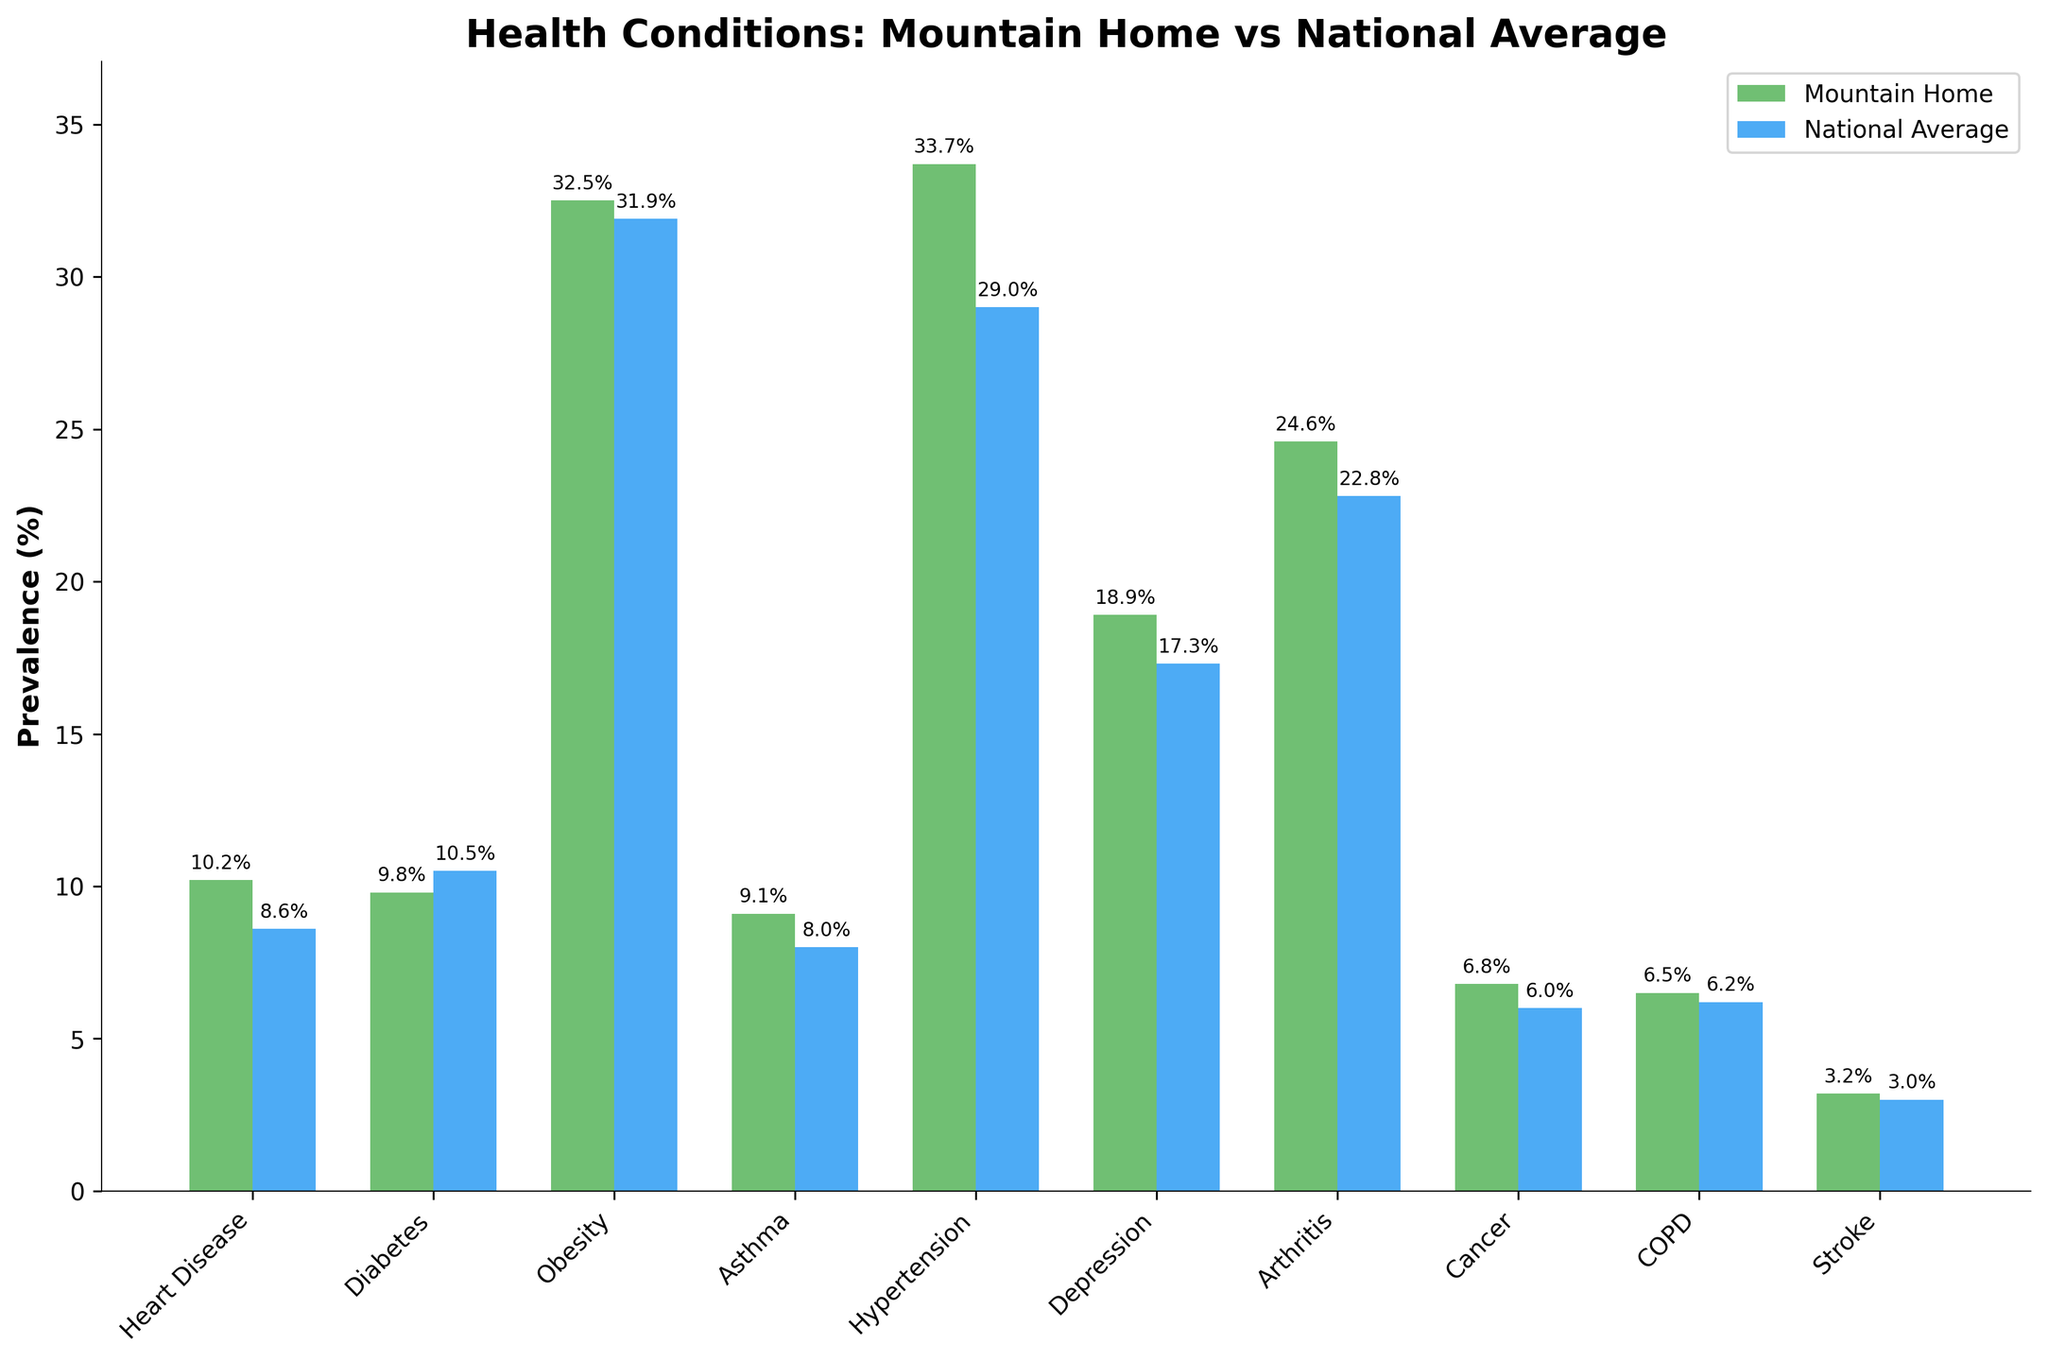Which health condition has the highest prevalence in Mountain Home? By examining the heights of the bars on the chart representing Mountain Home, the bar corresponding to 'Hypertension' is the highest, indicating the highest prevalence.
Answer: Hypertension How does the prevalence of Diabetes in Mountain Home compare to the national average? Comparing the height of the bars for 'Diabetes' in Mountain Home and the national average, the national average bar is higher.
Answer: National average is higher What is the difference in prevalence of Heart Disease between Mountain Home and the national average? The bar for Heart Disease in Mountain Home is at 10.2% while the national average bar is at 8.6%. The difference is 10.2% - 8.6%.
Answer: 1.6% Which health condition has the closest prevalence when comparing Mountain Home to the national average? By examining the differences in heights of the bars, 'COPD' has the closest values with Mountain Home at 6.5% and the national average at 6.2%.
Answer: COPD What is the combined prevalence of Obesity and Hypertension in Mountain Home? Adding the values from the bars: Obesity (32.5%) + Hypertension (33.7%).
Answer: 66.2% Is the prevalence of Asthma higher or lower in Mountain Home compared to the national average? By comparing the heights of the bars for Asthma, the bar for Mountain Home is higher at 9.1% compared to the national average at 8.0%.
Answer: Higher Which two conditions show the largest prevalence difference between Mountain Home and the national average? By calculating the difference for each condition, Hypertension shows the largest difference (33.7% - 29.0% = 4.7%) and Heart Disease has the second largest (10.2% - 8.6% = 1.6%).
Answer: Hypertension and Heart Disease What is the average prevalence of Depression and Arthritis in Mountain Home? The values from the bars are Depression (18.9%) and Arthritis (24.6%). Adding them and dividing by 2 gives (18.9 + 24.6) / 2.
Answer: 21.75% Which condition has a higher prevalence in Mountain Home than the national average but less than 10%? Conditions with bars higher for Mountain Home and less than 10%: Heart Disease at 10.2%, Diabetes at 9.8%, Asthma at 9.1%. Asthma fulfills the condition of being below 10%.
Answer: Asthma 